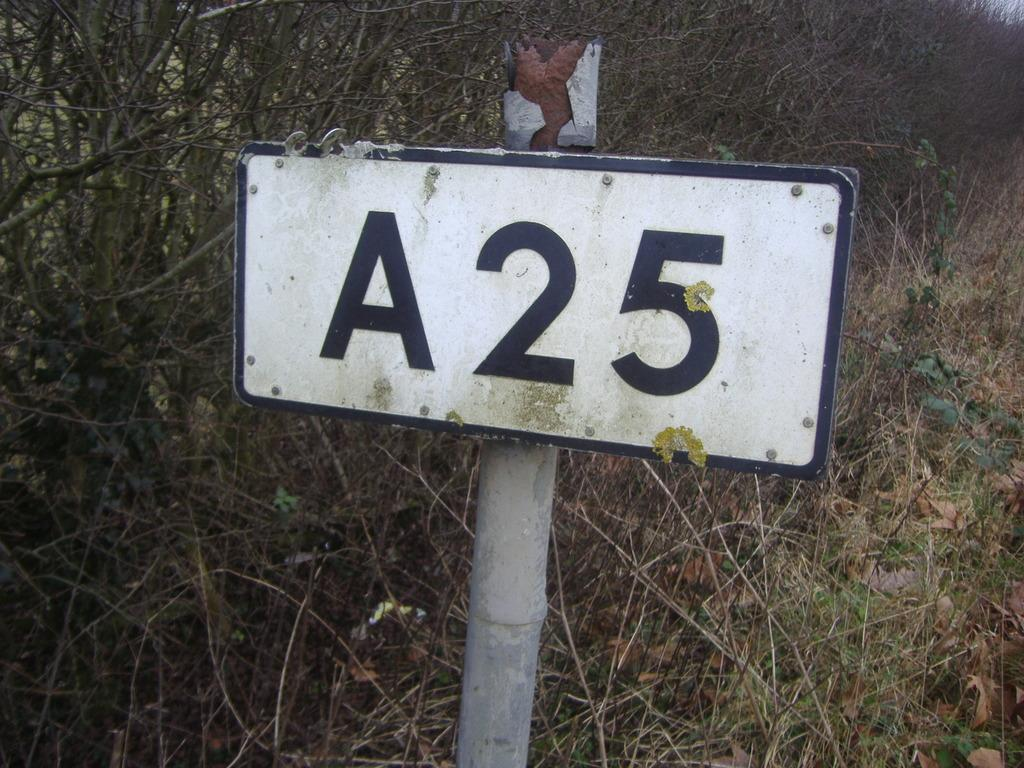<image>
Summarize the visual content of the image. White and black sign that says A25 outdoors. 